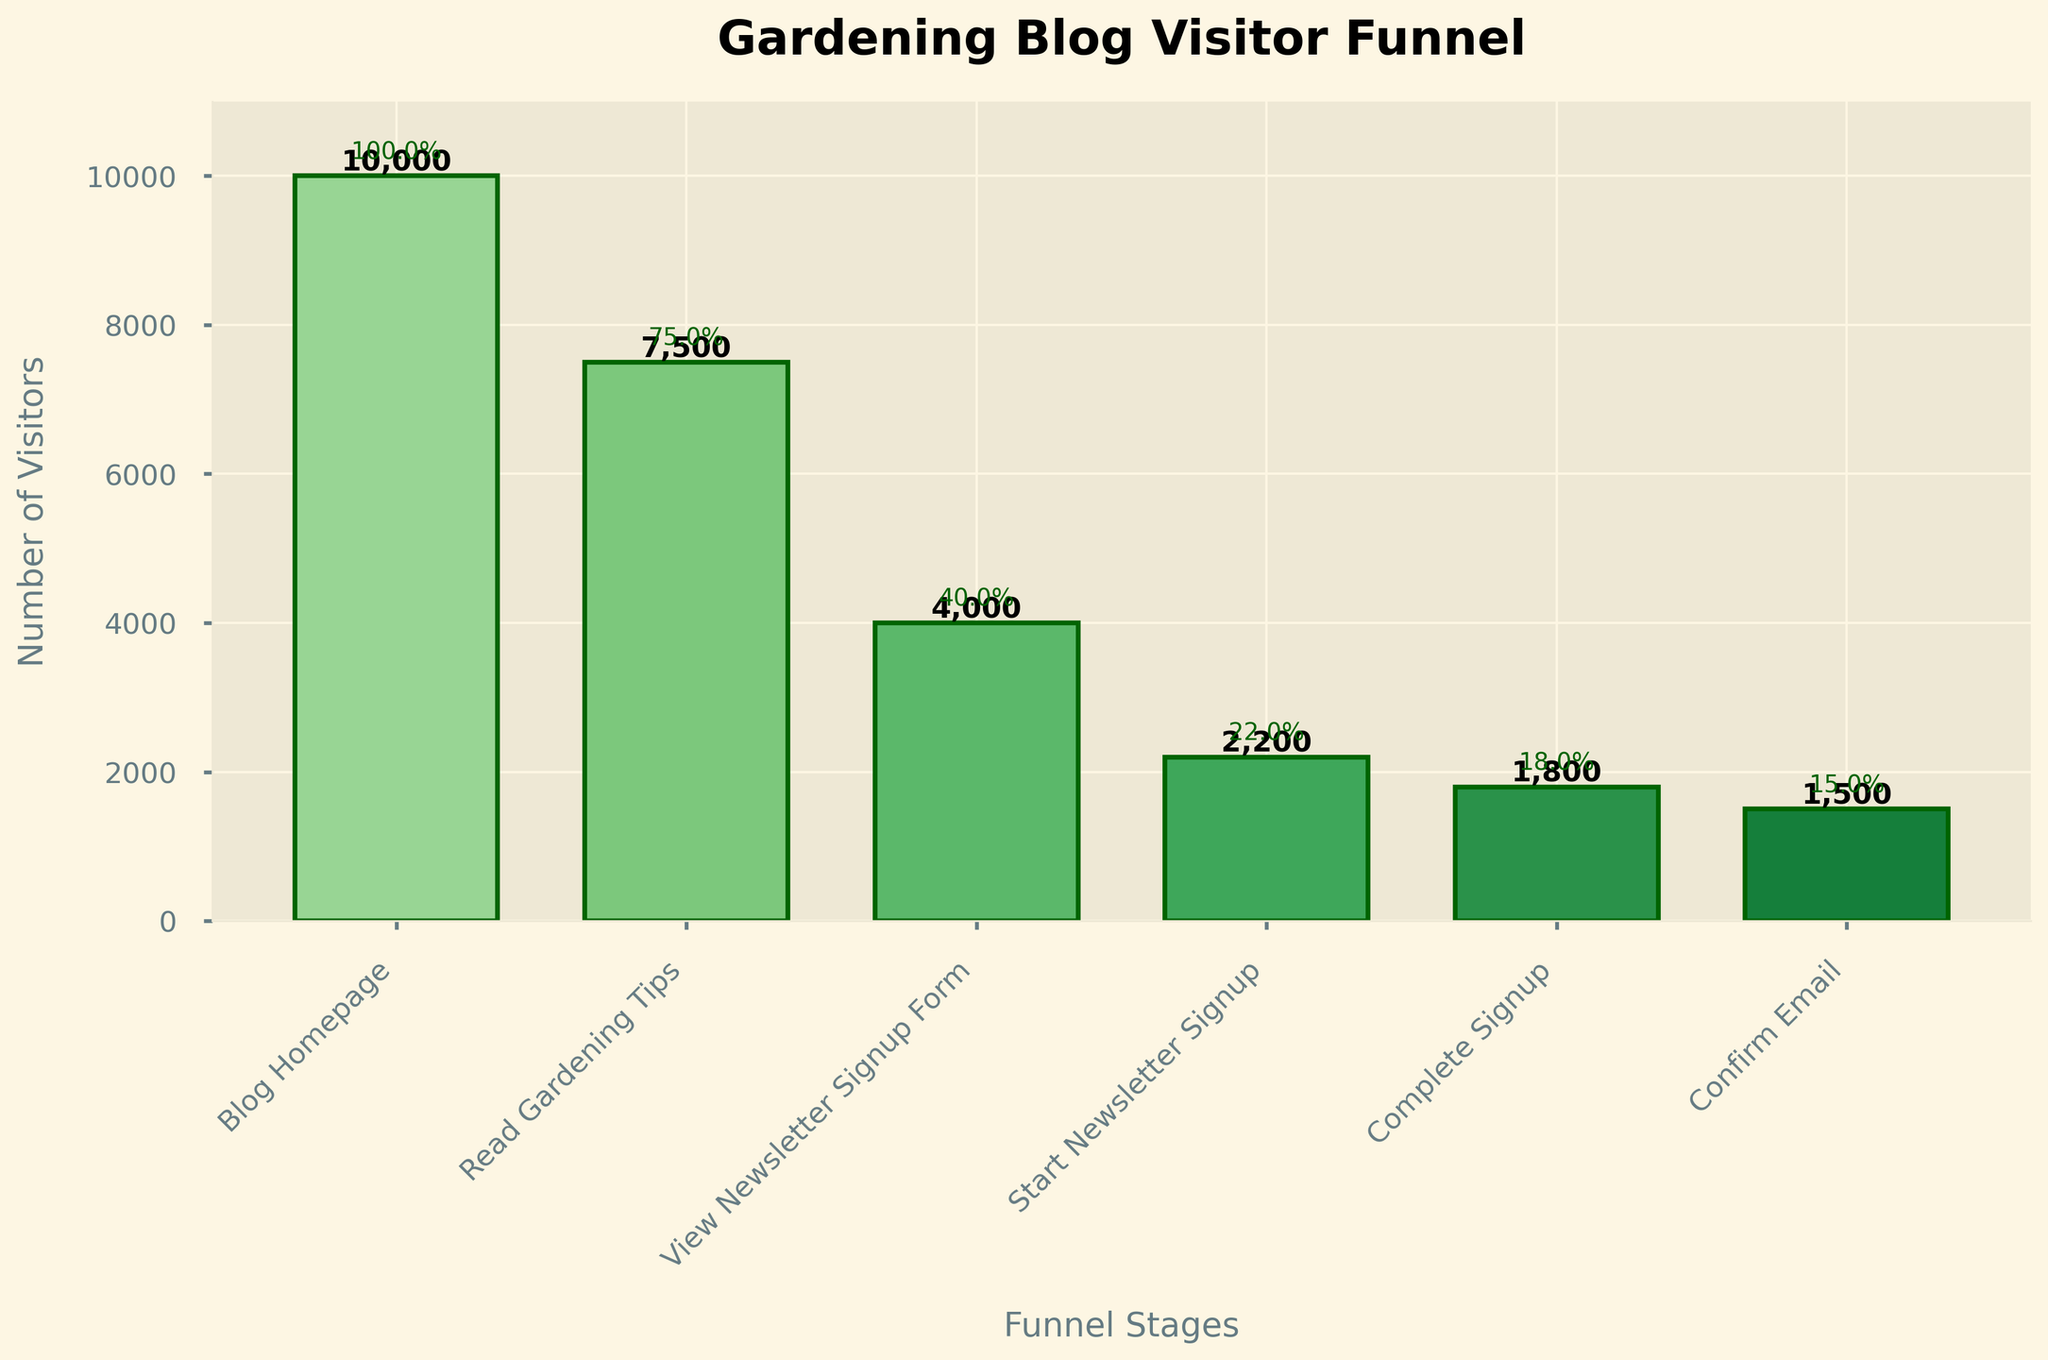What's the title of the chart? The chart title is located at the top and generally summarizes the content of the chart. Here, the title is bold and explicitly states the topic.
Answer: Gardening Blog Visitor Funnel How many total stages are there in the funnel? Count the number of distinct stages labeled on the x-axis of the chart to find the total number of stages.
Answer: 6 Which stage has the highest number of visitors? The initial stage generally has the highest number of visitors. Verify this by looking at the bar heights. The highest bar corresponds to the "Blog Homepage" stage.
Answer: Blog Homepage What percentage of visitors who start the newsletter signup complete it? Find the number of visitors who start the newsletter signup (2200) and those who complete it (1800). The percentage is (1800 / 2200) * 100.
Answer: 81.8% What's the difference in the number of visitors between the "View Newsletter Signup Form" and "Confirm Email" stages? Subtract the number of visitors at the "Confirm Email" stage (1500) from the "View Newsletter Signup Form" stage (4000).
Answer: 2500 Which stage has the lowest number of visitors? The lowest bar in the chart represents the stage with the fewest number of visitors. Check to see which bar is the smallest.
Answer: Confirm Email How many visitors read the gardening tips but do not view the newsletter signup form? Subtract the number of visitors at "View Newsletter Signup Form" (4000) from those at "Read Gardening Tips" (7500).
Answer: 3500 What is the overall conversion rate from the "Blog Homepage" to "Confirm Email"? Divide the number of visitors at "Confirm Email" (1500) by those at "Blog Homepage" (10000) and multiply by 100 to get the conversion rate.
Answer: 15% Which two consecutive stages have the greatest drop in visitor numbers? Compare the differences in visitor numbers between each consecutive pair of stages to find the greatest drop. Subtract as follows: 10000-7500, 7500-4000, 4000-2200, 2200-1800, 1800-1500. The greatest is 7500-4000.
Answer: Read Gardening Tips to View Newsletter Signup Form How many visitors do not complete the email confirmation after starting it? Subtract the number of visitors at "Confirm Email" (1500) from those at "Complete Signup" (1800).
Answer: 300 